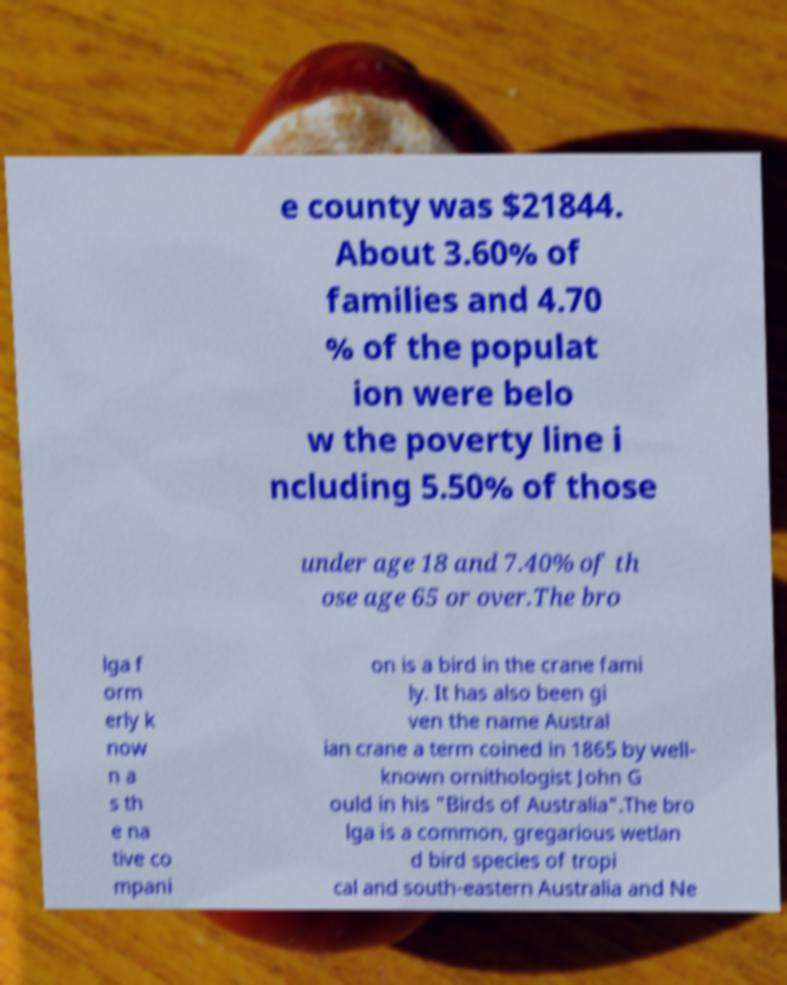For documentation purposes, I need the text within this image transcribed. Could you provide that? e county was $21844. About 3.60% of families and 4.70 % of the populat ion were belo w the poverty line i ncluding 5.50% of those under age 18 and 7.40% of th ose age 65 or over.The bro lga f orm erly k now n a s th e na tive co mpani on is a bird in the crane fami ly. It has also been gi ven the name Austral ian crane a term coined in 1865 by well- known ornithologist John G ould in his "Birds of Australia".The bro lga is a common, gregarious wetlan d bird species of tropi cal and south-eastern Australia and Ne 